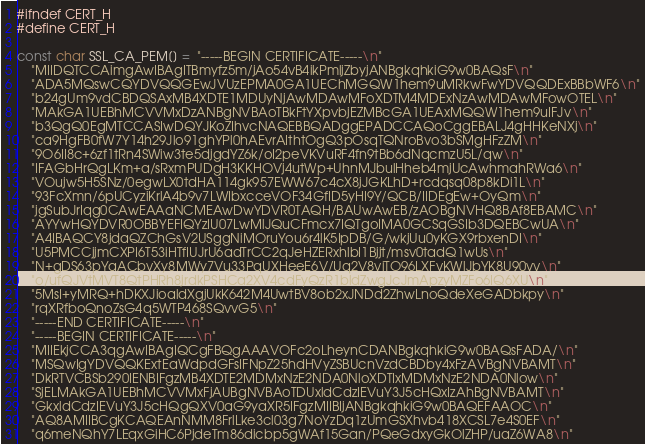<code> <loc_0><loc_0><loc_500><loc_500><_C_>#ifndef CERT_H
#define CERT_H

const char SSL_CA_PEM[] =  "-----BEGIN CERTIFICATE-----\n"
    "MIIDQTCCAimgAwIBAgITBmyfz5m/jAo54vB4ikPmljZbyjANBgkqhkiG9w0BAQsF\n"
    "ADA5MQswCQYDVQQGEwJVUzEPMA0GA1UEChMGQW1hem9uMRkwFwYDVQQDExBBbWF6\n"
    "b24gUm9vdCBDQSAxMB4XDTE1MDUyNjAwMDAwMFoXDTM4MDExNzAwMDAwMFowOTEL\n"
    "MAkGA1UEBhMCVVMxDzANBgNVBAoTBkFtYXpvbjEZMBcGA1UEAxMQQW1hem9uIFJv\n"
    "b3QgQ0EgMTCCASIwDQYJKoZIhvcNAQEBBQADggEPADCCAQoCggEBALJ4gHHKeNXj\n"
    "ca9HgFB0fW7Y14h29Jlo91ghYPl0hAEvrAIthtOgQ3pOsqTQNroBvo3bSMgHFzZM\n"
    "9O6II8c+6zf1tRn4SWiw3te5djgdYZ6k/oI2peVKVuRF4fn9tBb6dNqcmzU5L/qw\n"
    "IFAGbHrQgLKm+a/sRxmPUDgH3KKHOVj4utWp+UhnMJbulHheb4mjUcAwhmahRWa6\n"
    "VOujw5H5SNz/0egwLX0tdHA114gk957EWW67c4cX8jJGKLhD+rcdqsq08p8kDi1L\n"
    "93FcXmn/6pUCyziKrlA4b9v7LWIbxcceVOF34GfID5yHI9Y/QCB/IIDEgEw+OyQm\n"
    "jgSubJrIqg0CAwEAAaNCMEAwDwYDVR0TAQH/BAUwAwEB/zAOBgNVHQ8BAf8EBAMC\n"
    "AYYwHQYDVR0OBBYEFIQYzIU07LwMlJQuCFmcx7IQTgoIMA0GCSqGSIb3DQEBCwUA\n"
    "A4IBAQCY8jdaQZChGsV2USggNiMOruYou6r4lK5IpDB/G/wkjUu0yKGX9rbxenDI\n"
    "U5PMCCjjmCXPI6T53iHTfIUJrU6adTrCC2qJeHZERxhlbI1Bjjt/msv0tadQ1wUs\n"
    "N+gDS63pYaACbvXy8MWy7Vu33PqUXHeeE6V/Uq2V8viTO96LXFvKWlJbYK8U90vv\n"
    "o/ufQJVtMVT8QtPHRh8jrdkPSHCa2XV4cdFyQzR1bldZwgJcJmApzyMZFo6IQ6XU\n"
    "5MsI+yMRQ+hDKXJioaldXgjUkK642M4UwtBV8ob2xJNDd2ZhwLnoQdeXeGADbkpy\n"
    "rqXRfboQnoZsG4q5WTP468SQvvG5\n"
    "-----END CERTIFICATE-----\n"
    "-----BEGIN CERTIFICATE-----\n"
    "MIIEkjCCA3qgAwIBAgIQCgFBQgAAAVOFc2oLheynCDANBgkqhkiG9w0BAQsFADA/\n"
    "MSQwIgYDVQQKExtEaWdpdGFsIFNpZ25hdHVyZSBUcnVzdCBDby4xFzAVBgNVBAMT\n"
    "DkRTVCBSb290IENBIFgzMB4XDTE2MDMxNzE2NDA0NloXDTIxMDMxNzE2NDA0Nlow\n"
    "SjELMAkGA1UEBhMCVVMxFjAUBgNVBAoTDUxldCdzIEVuY3J5cHQxIzAhBgNVBAMT\n"
    "GkxldCdzIEVuY3J5cHQgQXV0aG9yaXR5IFgzMIIBIjANBgkqhkiG9w0BAQEFAAOC\n"
    "AQ8AMIIBCgKCAQEAnNMM8FrlLke3cl03g7NoYzDq1zUmGSXhvb418XCSL7e4S0EF\n"
    "q6meNQhY7LEqxGiHC6PjdeTm86dicbp5gWAf15Gan/PQeGdxyGkOlZHP/uaZ6WA8\n"</code> 